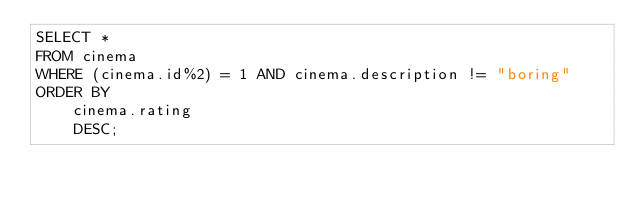Convert code to text. <code><loc_0><loc_0><loc_500><loc_500><_SQL_>SELECT * 
FROM cinema
WHERE (cinema.id%2) = 1 AND cinema.description != "boring"
ORDER BY
    cinema.rating
    DESC;
</code> 